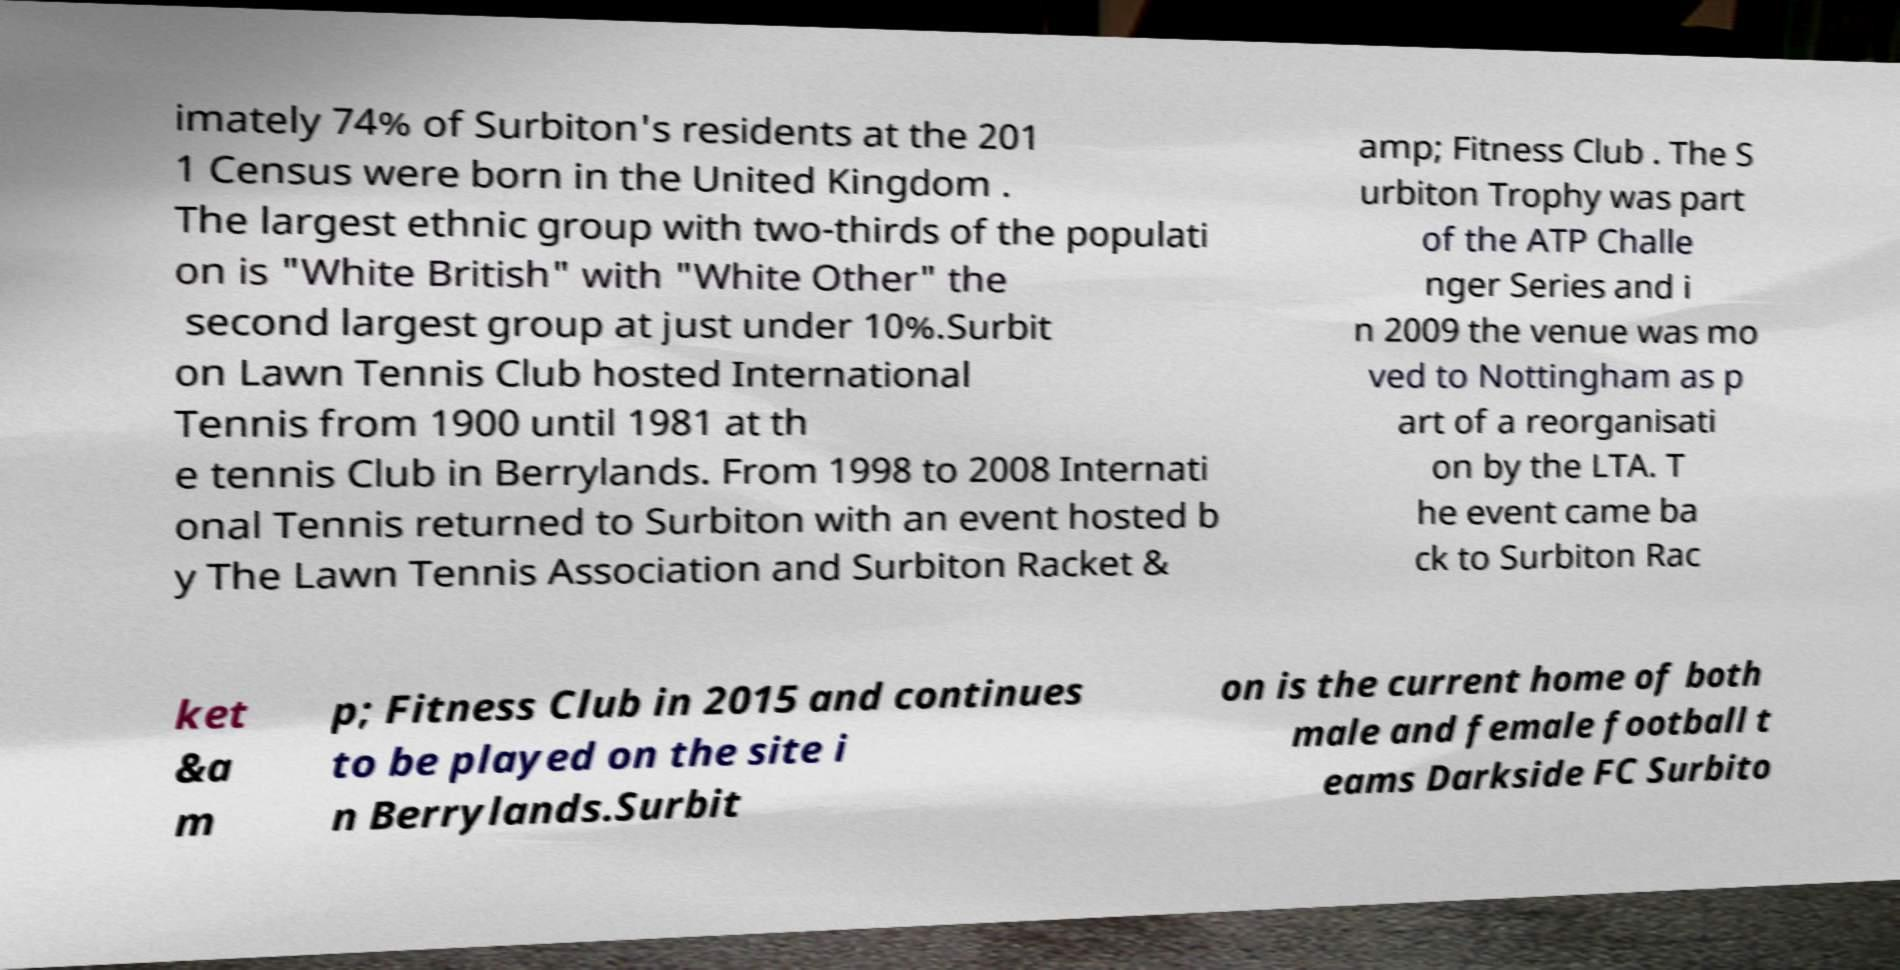Can you accurately transcribe the text from the provided image for me? imately 74% of Surbiton's residents at the 201 1 Census were born in the United Kingdom . The largest ethnic group with two-thirds of the populati on is "White British" with "White Other" the second largest group at just under 10%.Surbit on Lawn Tennis Club hosted International Tennis from 1900 until 1981 at th e tennis Club in Berrylands. From 1998 to 2008 Internati onal Tennis returned to Surbiton with an event hosted b y The Lawn Tennis Association and Surbiton Racket & amp; Fitness Club . The S urbiton Trophy was part of the ATP Challe nger Series and i n 2009 the venue was mo ved to Nottingham as p art of a reorganisati on by the LTA. T he event came ba ck to Surbiton Rac ket &a m p; Fitness Club in 2015 and continues to be played on the site i n Berrylands.Surbit on is the current home of both male and female football t eams Darkside FC Surbito 